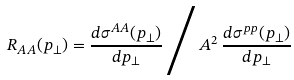Convert formula to latex. <formula><loc_0><loc_0><loc_500><loc_500>R _ { A A } ( p _ { \perp } ) = \frac { d \sigma ^ { A A } ( p _ { \perp } ) } { d p _ { \perp } } \, \Big / \, A ^ { 2 } \, \frac { d \sigma ^ { p p } ( p _ { \perp } ) } { d p _ { \perp } }</formula> 